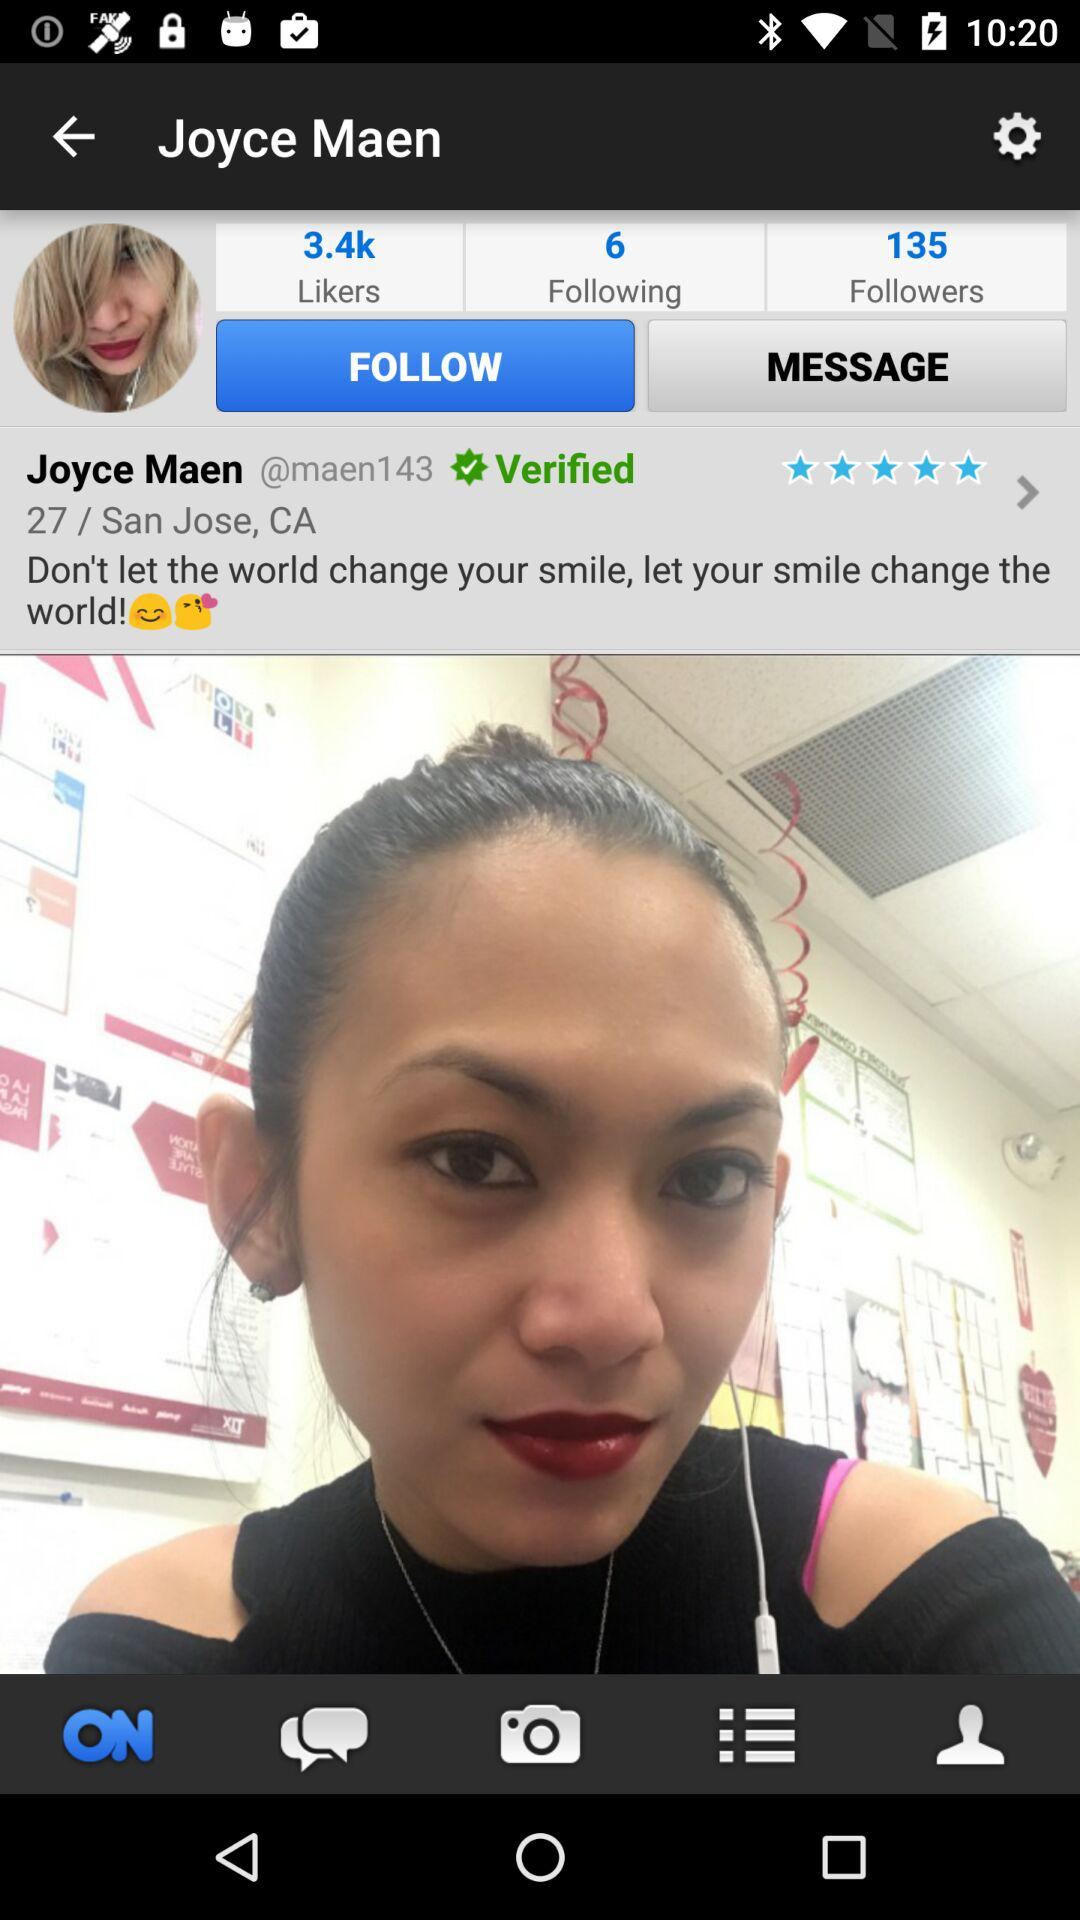How many more followers does Joyce Maen have than following?
Answer the question using a single word or phrase. 129 